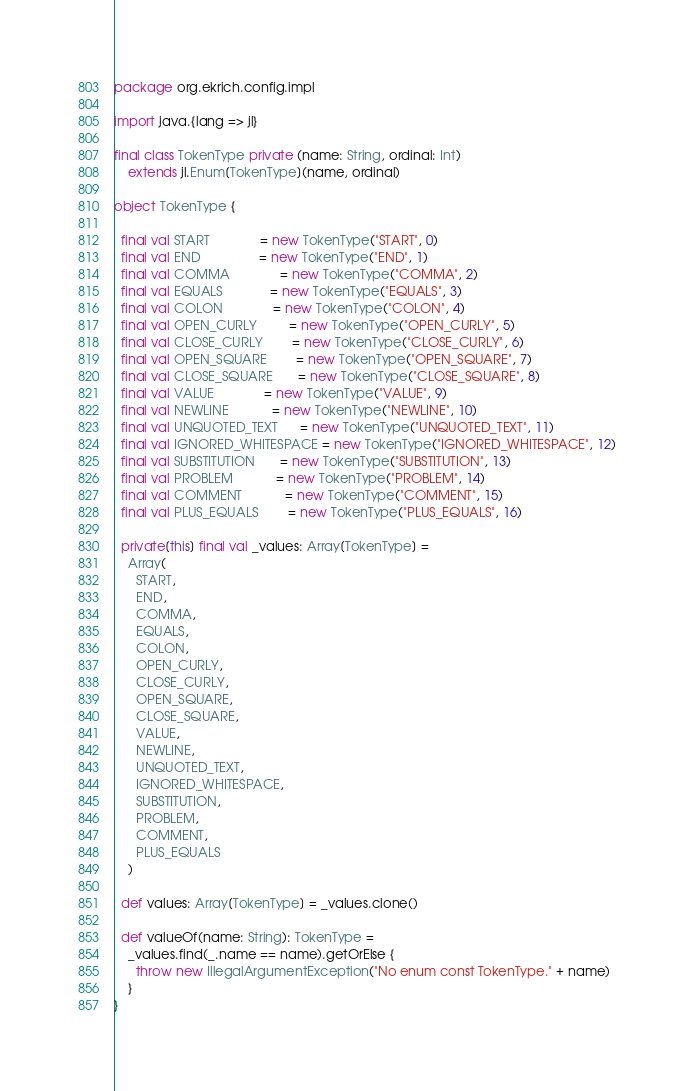Convert code to text. <code><loc_0><loc_0><loc_500><loc_500><_Scala_>package org.ekrich.config.impl

import java.{lang => jl}

final class TokenType private (name: String, ordinal: Int)
    extends jl.Enum[TokenType](name, ordinal)

object TokenType {

  final val START              = new TokenType("START", 0)
  final val END                = new TokenType("END", 1)
  final val COMMA              = new TokenType("COMMA", 2)
  final val EQUALS             = new TokenType("EQUALS", 3)
  final val COLON              = new TokenType("COLON", 4)
  final val OPEN_CURLY         = new TokenType("OPEN_CURLY", 5)
  final val CLOSE_CURLY        = new TokenType("CLOSE_CURLY", 6)
  final val OPEN_SQUARE        = new TokenType("OPEN_SQUARE", 7)
  final val CLOSE_SQUARE       = new TokenType("CLOSE_SQUARE", 8)
  final val VALUE              = new TokenType("VALUE", 9)
  final val NEWLINE            = new TokenType("NEWLINE", 10)
  final val UNQUOTED_TEXT      = new TokenType("UNQUOTED_TEXT", 11)
  final val IGNORED_WHITESPACE = new TokenType("IGNORED_WHITESPACE", 12)
  final val SUBSTITUTION       = new TokenType("SUBSTITUTION", 13)
  final val PROBLEM            = new TokenType("PROBLEM", 14)
  final val COMMENT            = new TokenType("COMMENT", 15)
  final val PLUS_EQUALS        = new TokenType("PLUS_EQUALS", 16)

  private[this] final val _values: Array[TokenType] =
    Array(
      START,
      END,
      COMMA,
      EQUALS,
      COLON,
      OPEN_CURLY,
      CLOSE_CURLY,
      OPEN_SQUARE,
      CLOSE_SQUARE,
      VALUE,
      NEWLINE,
      UNQUOTED_TEXT,
      IGNORED_WHITESPACE,
      SUBSTITUTION,
      PROBLEM,
      COMMENT,
      PLUS_EQUALS
    )

  def values: Array[TokenType] = _values.clone()

  def valueOf(name: String): TokenType =
    _values.find(_.name == name).getOrElse {
      throw new IllegalArgumentException("No enum const TokenType." + name)
    }
}
</code> 